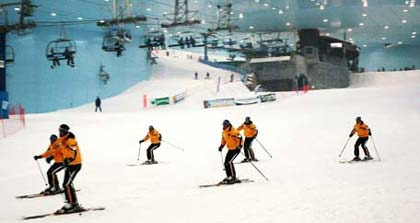What is the approximate length of the ski slope visible in the image? The ski slope visible in the image appears to be moderately long, allowing for a decent downhill run for the skiers. While it's hard to provide exact measurements without more context, it looks like it offers enough length for a variety of skiing maneuvers. Do you think this indoor facility also offers other winter sports activities? It's quite possible that this indoor facility offers other winter sports activities in addition to skiing. Many indoor snow facilities are designed to cater to a range of activities such as snowboarding, tubing, or even ice skating, providing a comprehensive winter sports experience. 